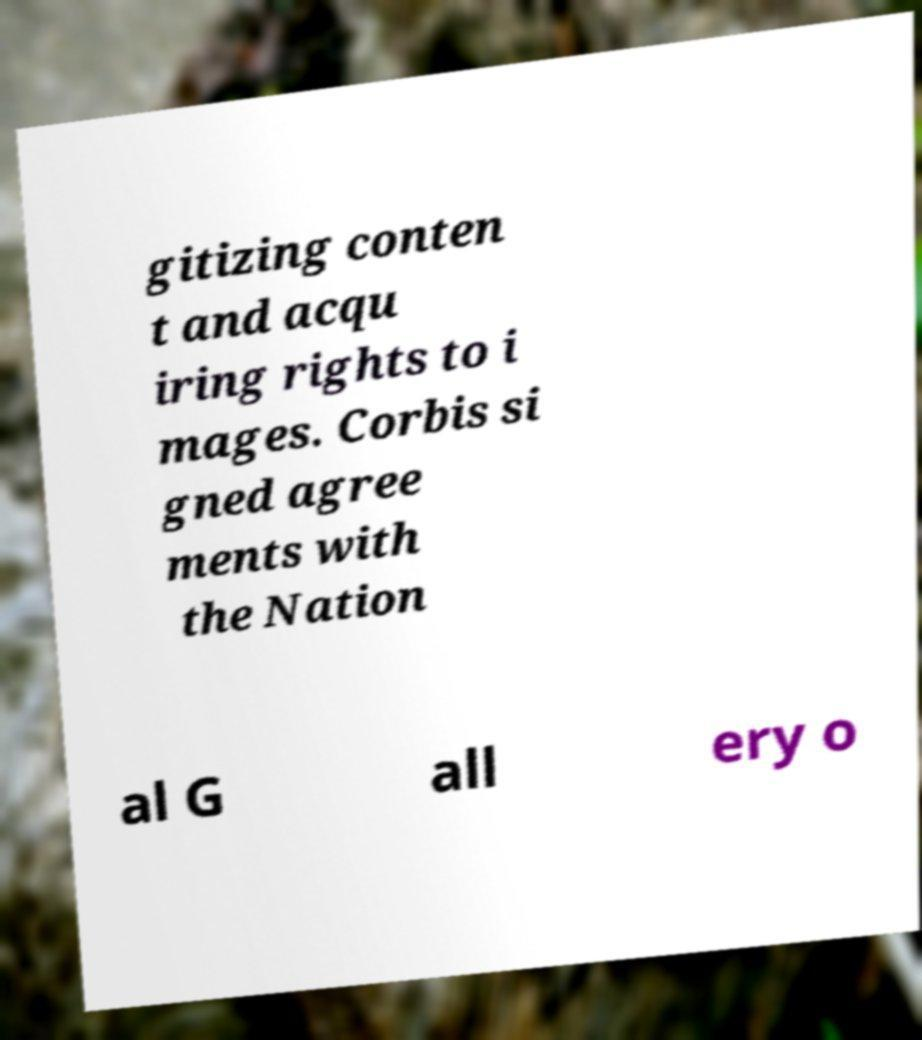Please read and relay the text visible in this image. What does it say? gitizing conten t and acqu iring rights to i mages. Corbis si gned agree ments with the Nation al G all ery o 